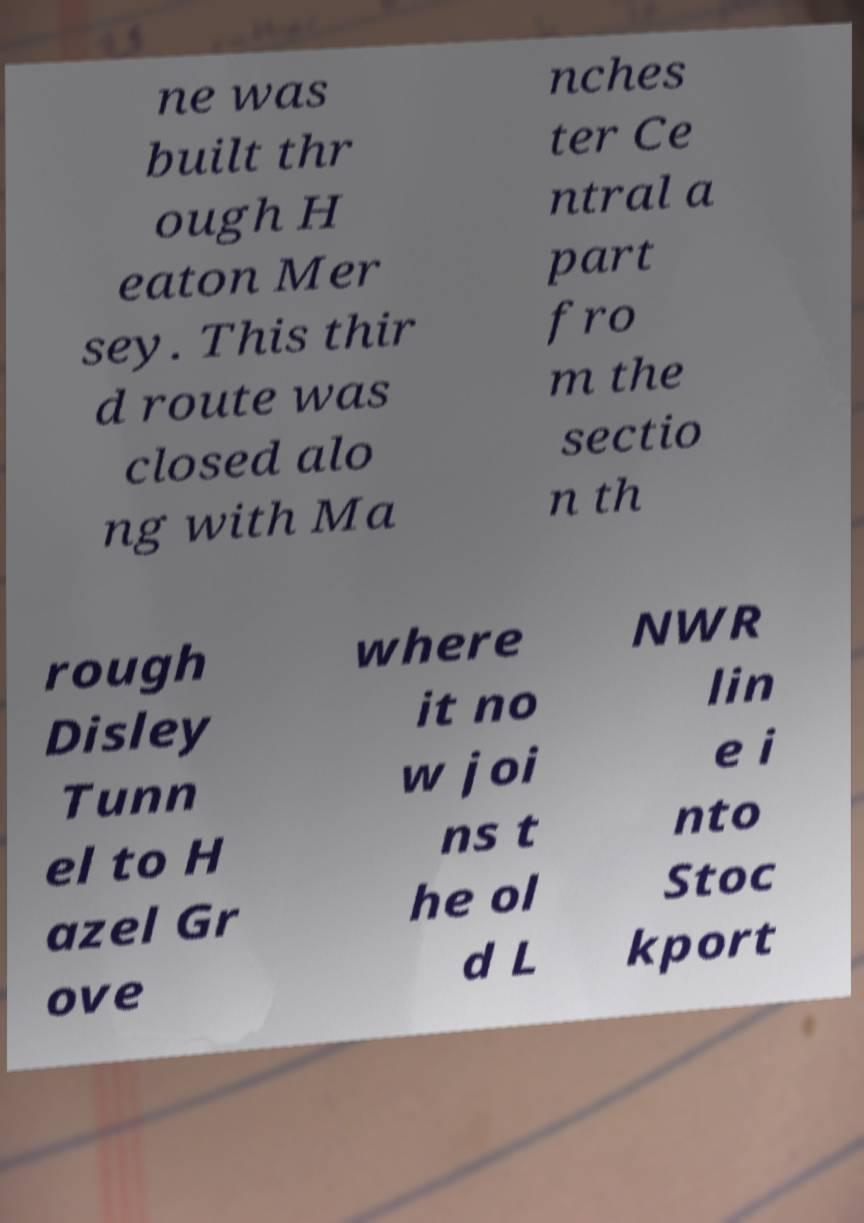I need the written content from this picture converted into text. Can you do that? ne was built thr ough H eaton Mer sey. This thir d route was closed alo ng with Ma nches ter Ce ntral a part fro m the sectio n th rough Disley Tunn el to H azel Gr ove where it no w joi ns t he ol d L NWR lin e i nto Stoc kport 